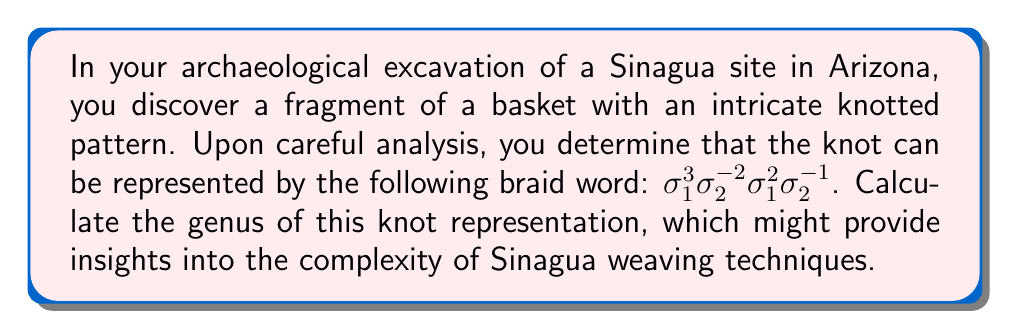What is the answer to this math problem? To calculate the genus of the knot representation, we'll follow these steps:

1) First, we need to determine the number of crossings in the knot. The braid word $\sigma_1^3 \sigma_2^{-2} \sigma_1^2 \sigma_2^{-1}$ represents:
   - 3 positive crossings of strand 1 over strand 2
   - 2 negative crossings of strand 2 over strand 3
   - 2 positive crossings of strand 1 over strand 2
   - 1 negative crossing of strand 2 over strand 3
   Total number of crossings: $3 + 2 + 2 + 1 = 8$

2) Next, we need to calculate the number of Seifert circles. To do this, we'll draw the Seifert surface:
   - Start with 3 parallel strands (as it's a 3-strand braid)
   - Connect the top of each strand to the bottom of the corresponding strand
   - Smooth out each crossing according to the orientation
   This process results in 2 Seifert circles.

3) Now we can use the formula for the genus of a knot:

   $$g = \frac{1}{2}(c - s + 1)$$

   Where $g$ is the genus, $c$ is the number of crossings, and $s$ is the number of Seifert circles.

4) Substituting our values:

   $$g = \frac{1}{2}(8 - 2 + 1) = \frac{1}{2}(7) = 3.5$$

5) Since the genus must be an integer, we round up to the nearest whole number.

Therefore, the genus of this knot representation is 4.
Answer: 4 